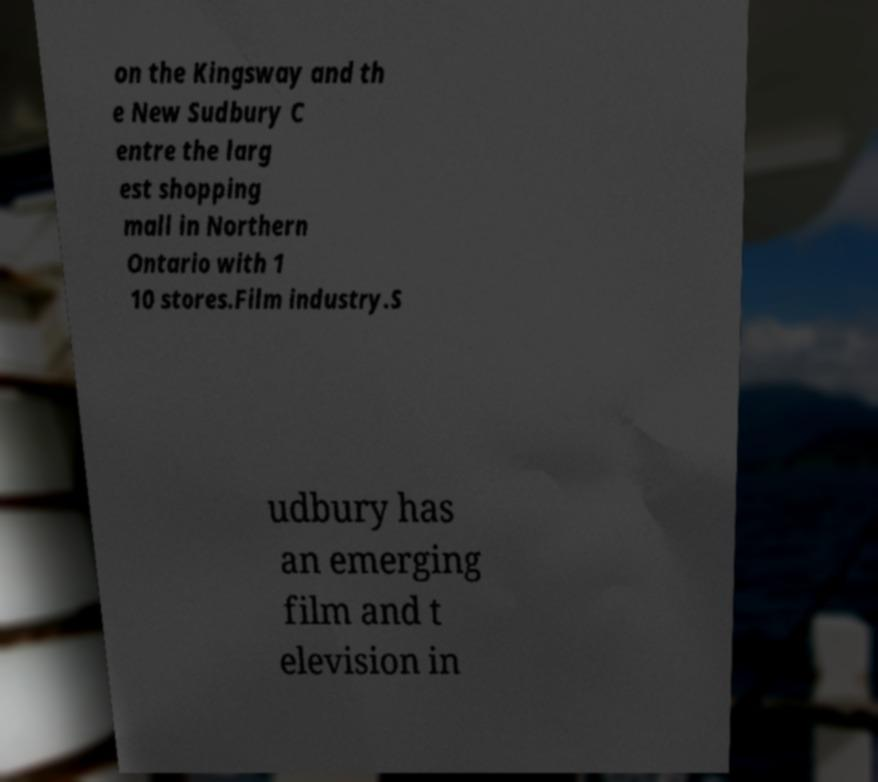I need the written content from this picture converted into text. Can you do that? on the Kingsway and th e New Sudbury C entre the larg est shopping mall in Northern Ontario with 1 10 stores.Film industry.S udbury has an emerging film and t elevision in 